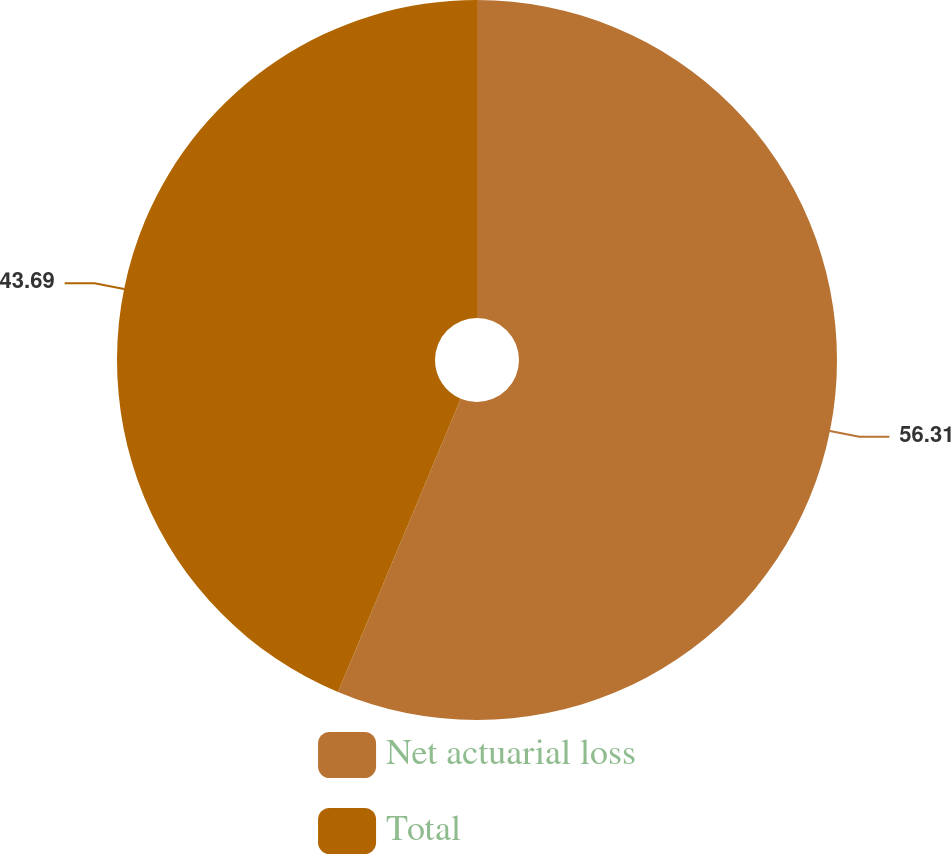Convert chart. <chart><loc_0><loc_0><loc_500><loc_500><pie_chart><fcel>Net actuarial loss<fcel>Total<nl><fcel>56.31%<fcel>43.69%<nl></chart> 